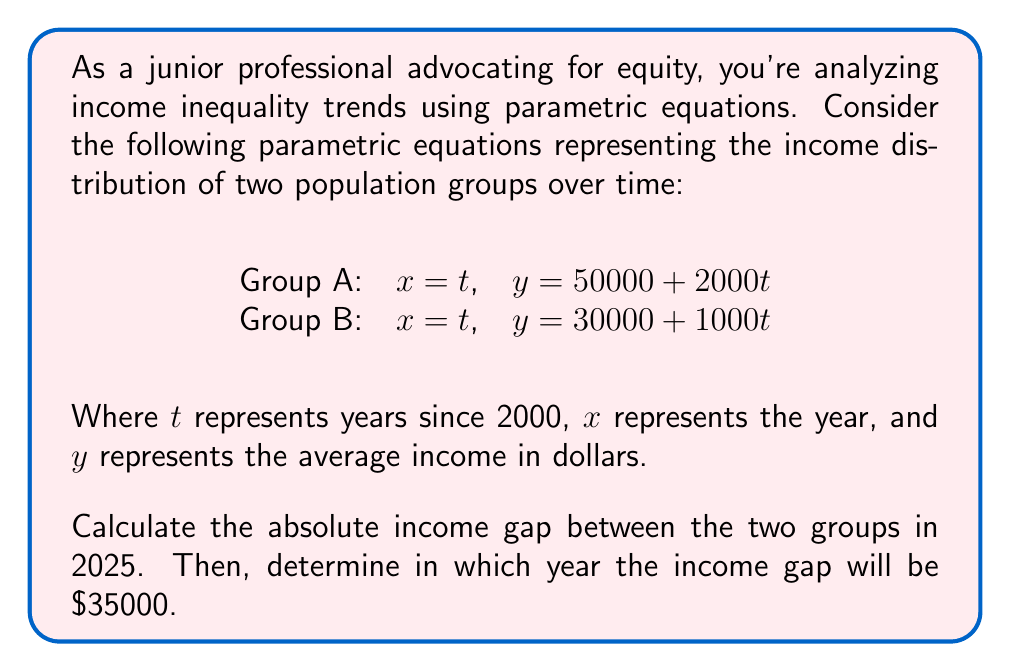Show me your answer to this math problem. To solve this problem, we'll follow these steps:

1. Calculate the income gap in 2025:
   For 2025, $t = 2025 - 2000 = 25$
   
   Group A income: $y_A = 50000 + 2000(25) = 100000$
   Group B income: $y_B = 30000 + 1000(25) = 55000$
   
   Income gap in 2025: $100000 - 55000 = 45000$

2. Find when the income gap is $35000:
   Let's set up an equation for the income gap:
   
   $$(50000 + 2000t) - (30000 + 1000t) = 35000$$
   
   Simplify:
   $20000 + 1000t = 35000$
   
   Solve for $t$:
   $1000t = 15000$
   $t = 15$
   
   The year when $t = 15$ is $2000 + 15 = 2015$
Answer: The absolute income gap between the two groups in 2025 is $45000. The income gap will be $35000 in the year 2015. 